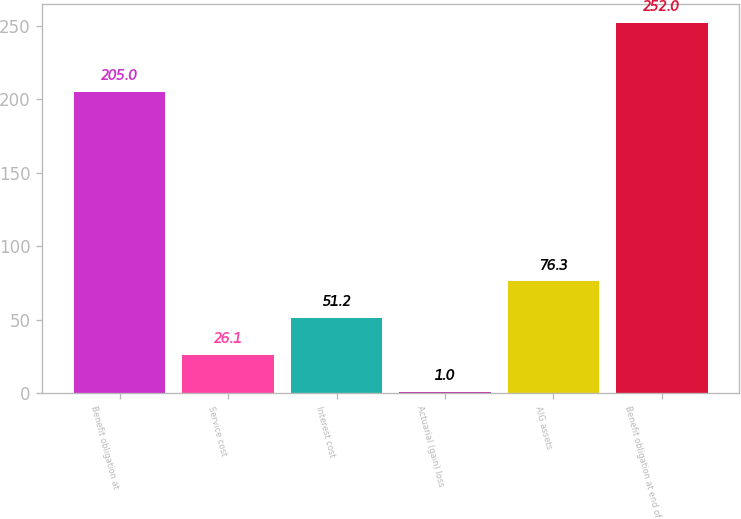<chart> <loc_0><loc_0><loc_500><loc_500><bar_chart><fcel>Benefit obligation at<fcel>Service cost<fcel>Interest cost<fcel>Actuarial (gain) loss<fcel>AIG assets<fcel>Benefit obligation at end of<nl><fcel>205<fcel>26.1<fcel>51.2<fcel>1<fcel>76.3<fcel>252<nl></chart> 